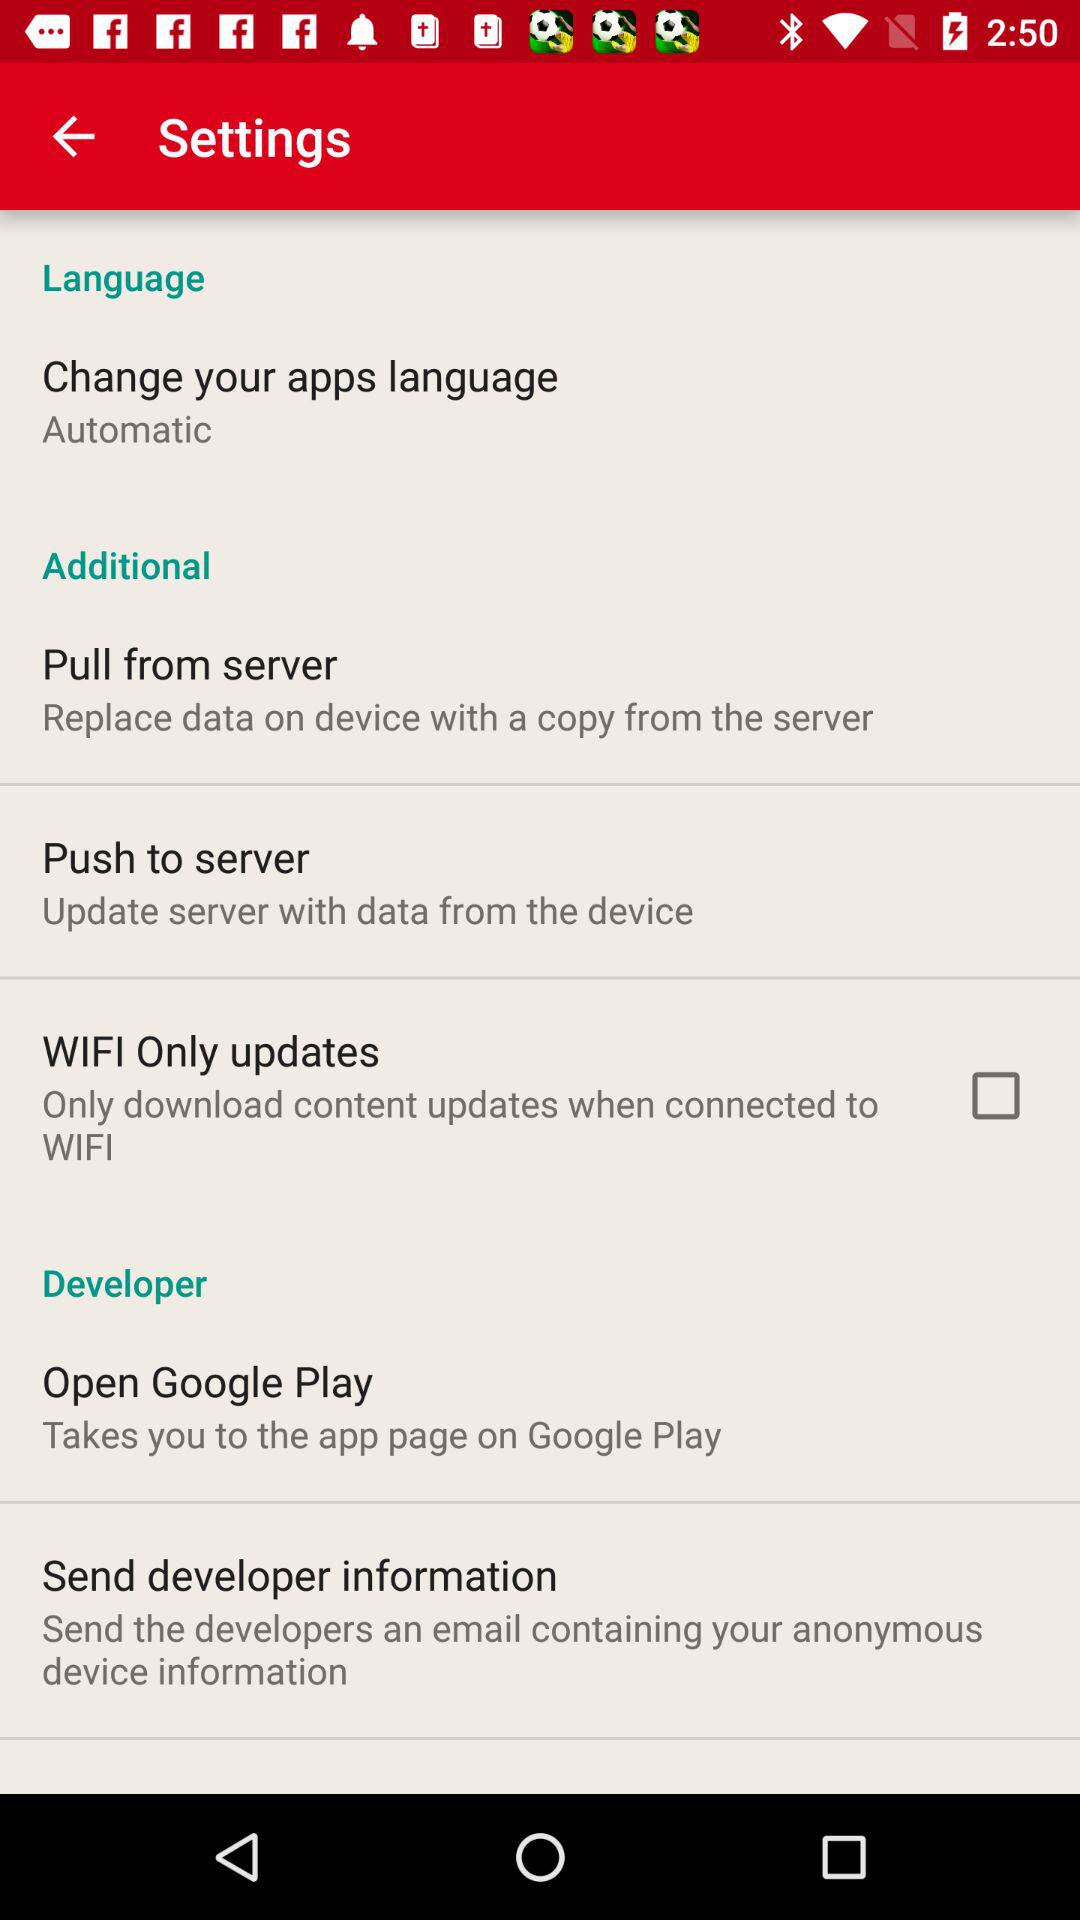Which content updates when we connect to WiFi? When you connect to WiFi only download content updates. 